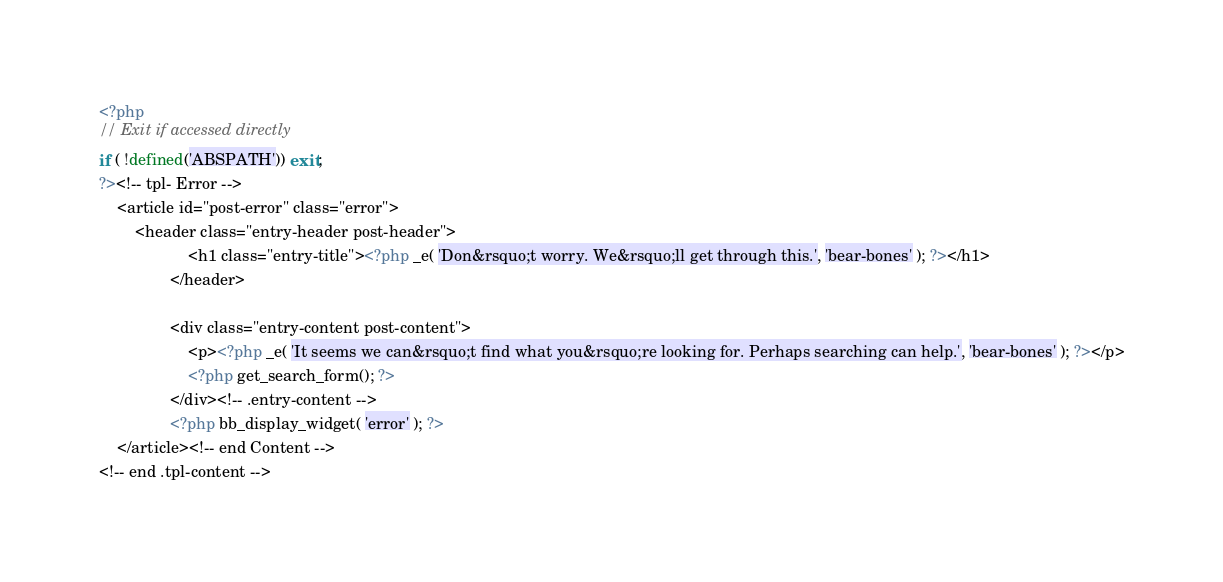<code> <loc_0><loc_0><loc_500><loc_500><_PHP_><?php
// Exit if accessed directly
if ( !defined('ABSPATH')) exit;
?><!-- tpl- Error -->
	<article id="post-error" class="error">
		<header class="entry-header post-header">
					<h1 class="entry-title"><?php _e( 'Don&rsquo;t worry. We&rsquo;ll get through this.', 'bear-bones' ); ?></h1>
				</header>

				<div class="entry-content post-content">
					<p><?php _e( 'It seems we can&rsquo;t find what you&rsquo;re looking for. Perhaps searching can help.', 'bear-bones' ); ?></p>
					<?php get_search_form(); ?>
				</div><!-- .entry-content -->
				<?php bb_display_widget( 'error' ); ?>
	</article><!-- end Content -->
<!-- end .tpl-content --></code> 